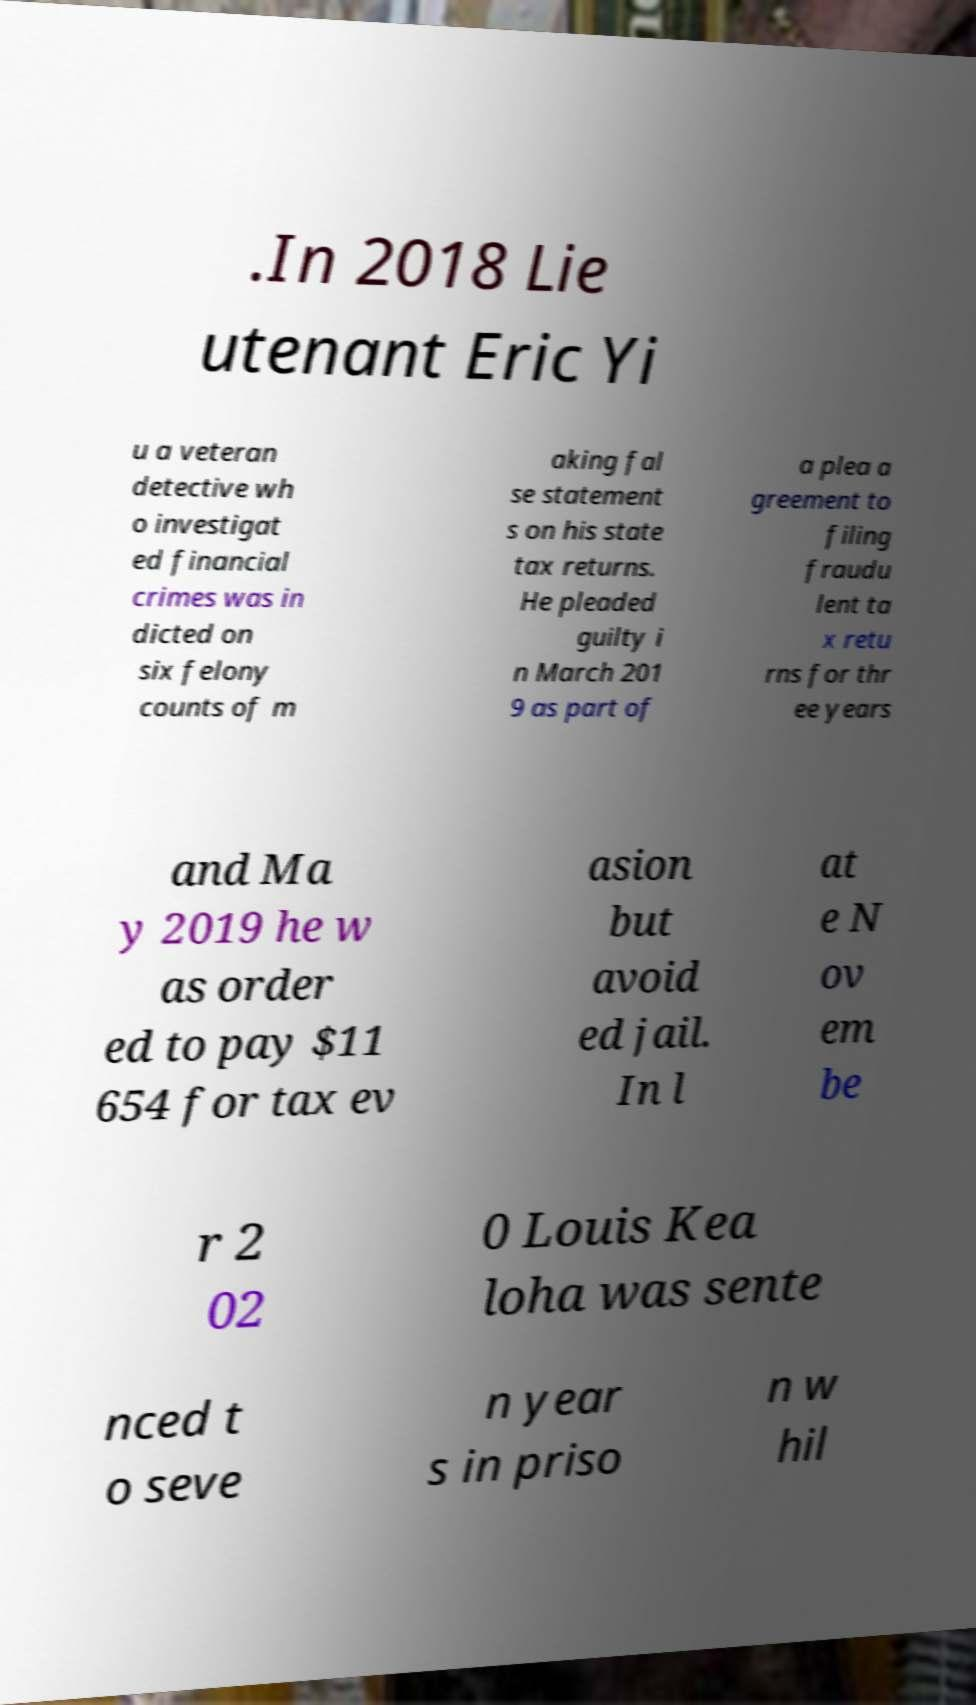There's text embedded in this image that I need extracted. Can you transcribe it verbatim? .In 2018 Lie utenant Eric Yi u a veteran detective wh o investigat ed financial crimes was in dicted on six felony counts of m aking fal se statement s on his state tax returns. He pleaded guilty i n March 201 9 as part of a plea a greement to filing fraudu lent ta x retu rns for thr ee years and Ma y 2019 he w as order ed to pay $11 654 for tax ev asion but avoid ed jail. In l at e N ov em be r 2 02 0 Louis Kea loha was sente nced t o seve n year s in priso n w hil 